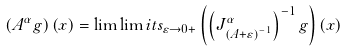Convert formula to latex. <formula><loc_0><loc_0><loc_500><loc_500>\left ( A ^ { \alpha } g \right ) ( x ) = \lim \lim i t s _ { \varepsilon \rightarrow 0 + } \left ( \left ( J ^ { \alpha } _ { \left ( A + \varepsilon \right ) ^ { - 1 } } \right ) ^ { - 1 } g \right ) ( x )</formula> 